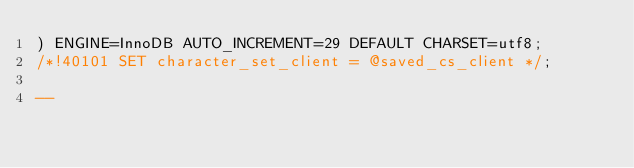<code> <loc_0><loc_0><loc_500><loc_500><_SQL_>) ENGINE=InnoDB AUTO_INCREMENT=29 DEFAULT CHARSET=utf8;
/*!40101 SET character_set_client = @saved_cs_client */;

--</code> 